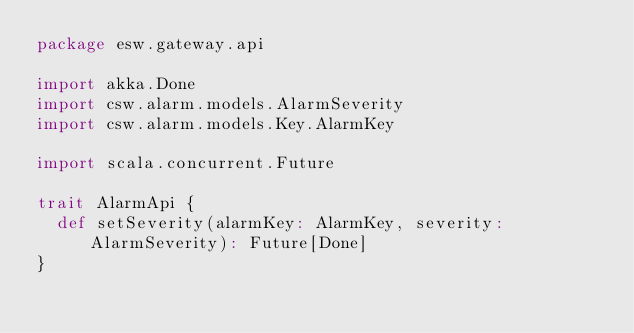Convert code to text. <code><loc_0><loc_0><loc_500><loc_500><_Scala_>package esw.gateway.api

import akka.Done
import csw.alarm.models.AlarmSeverity
import csw.alarm.models.Key.AlarmKey

import scala.concurrent.Future

trait AlarmApi {
  def setSeverity(alarmKey: AlarmKey, severity: AlarmSeverity): Future[Done]
}
</code> 